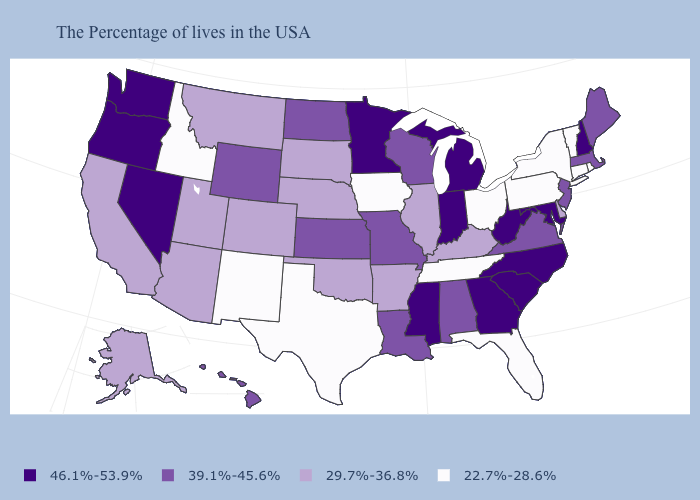What is the value of New Hampshire?
Be succinct. 46.1%-53.9%. Which states have the highest value in the USA?
Keep it brief. New Hampshire, Maryland, North Carolina, South Carolina, West Virginia, Georgia, Michigan, Indiana, Mississippi, Minnesota, Nevada, Washington, Oregon. Among the states that border Michigan , does Ohio have the lowest value?
Concise answer only. Yes. What is the value of Alaska?
Short answer required. 29.7%-36.8%. Name the states that have a value in the range 39.1%-45.6%?
Answer briefly. Maine, Massachusetts, New Jersey, Virginia, Alabama, Wisconsin, Louisiana, Missouri, Kansas, North Dakota, Wyoming, Hawaii. Among the states that border North Carolina , which have the highest value?
Concise answer only. South Carolina, Georgia. What is the value of Minnesota?
Answer briefly. 46.1%-53.9%. What is the highest value in states that border South Dakota?
Be succinct. 46.1%-53.9%. Which states have the highest value in the USA?
Concise answer only. New Hampshire, Maryland, North Carolina, South Carolina, West Virginia, Georgia, Michigan, Indiana, Mississippi, Minnesota, Nevada, Washington, Oregon. What is the value of Colorado?
Short answer required. 29.7%-36.8%. Name the states that have a value in the range 39.1%-45.6%?
Answer briefly. Maine, Massachusetts, New Jersey, Virginia, Alabama, Wisconsin, Louisiana, Missouri, Kansas, North Dakota, Wyoming, Hawaii. What is the lowest value in states that border South Dakota?
Quick response, please. 22.7%-28.6%. Which states have the lowest value in the Northeast?
Concise answer only. Rhode Island, Vermont, Connecticut, New York, Pennsylvania. Does New Hampshire have the highest value in the USA?
Answer briefly. Yes. What is the highest value in states that border West Virginia?
Give a very brief answer. 46.1%-53.9%. 